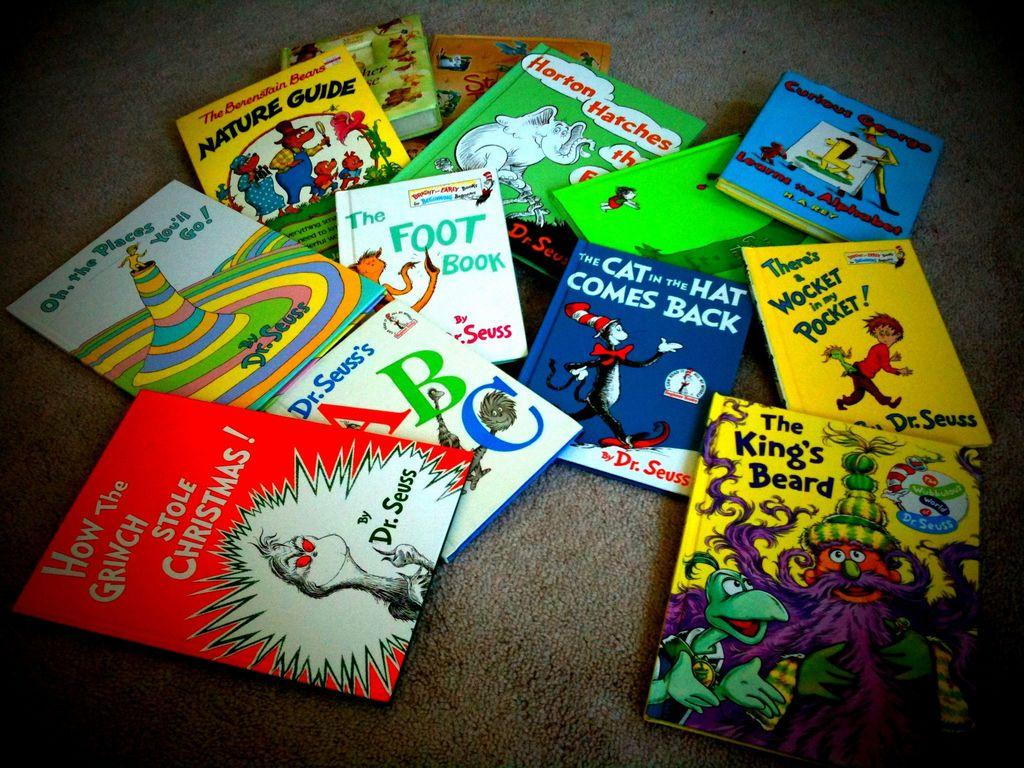What objects are present in the image? There are books in the image. Where are the books located? The books are on a surface. What can be seen on the books? The books have text and cartoon images on them. What type of haircut does the aunt have in the image? There is no aunt or haircut present in the image; it only features books with text and cartoon images. 